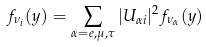<formula> <loc_0><loc_0><loc_500><loc_500>f _ { \nu _ { i } } ( y ) = \sum _ { \alpha = e , \mu , \tau } | U _ { \alpha i } | ^ { 2 } f _ { \nu _ { \alpha } } ( y )</formula> 